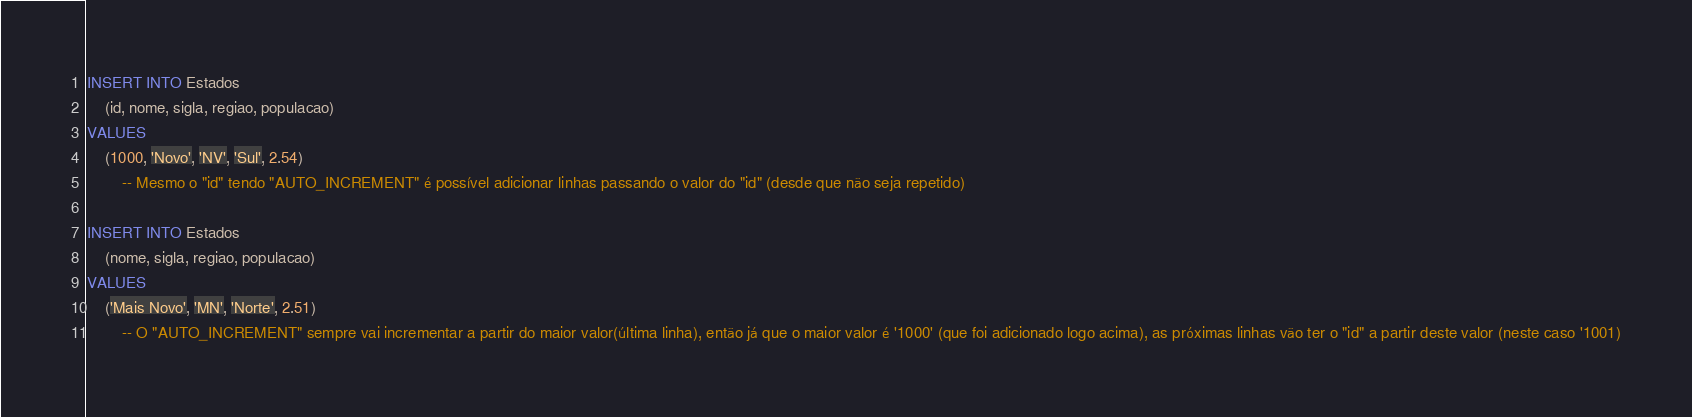Convert code to text. <code><loc_0><loc_0><loc_500><loc_500><_SQL_>INSERT INTO Estados
    (id, nome, sigla, regiao, populacao)
VALUES
    (1000, 'Novo', 'NV', 'Sul', 2.54)
        -- Mesmo o "id" tendo "AUTO_INCREMENT" é possível adicionar linhas passando o valor do "id" (desde que não seja repetido)

INSERT INTO Estados
    (nome, sigla, regiao, populacao)
VALUES
    ('Mais Novo', 'MN', 'Norte', 2.51)
        -- O "AUTO_INCREMENT" sempre vai incrementar a partir do maior valor(última linha), então já que o maior valor é '1000' (que foi adicionado logo acima), as próximas linhas vão ter o "id" a partir deste valor (neste caso '1001)</code> 